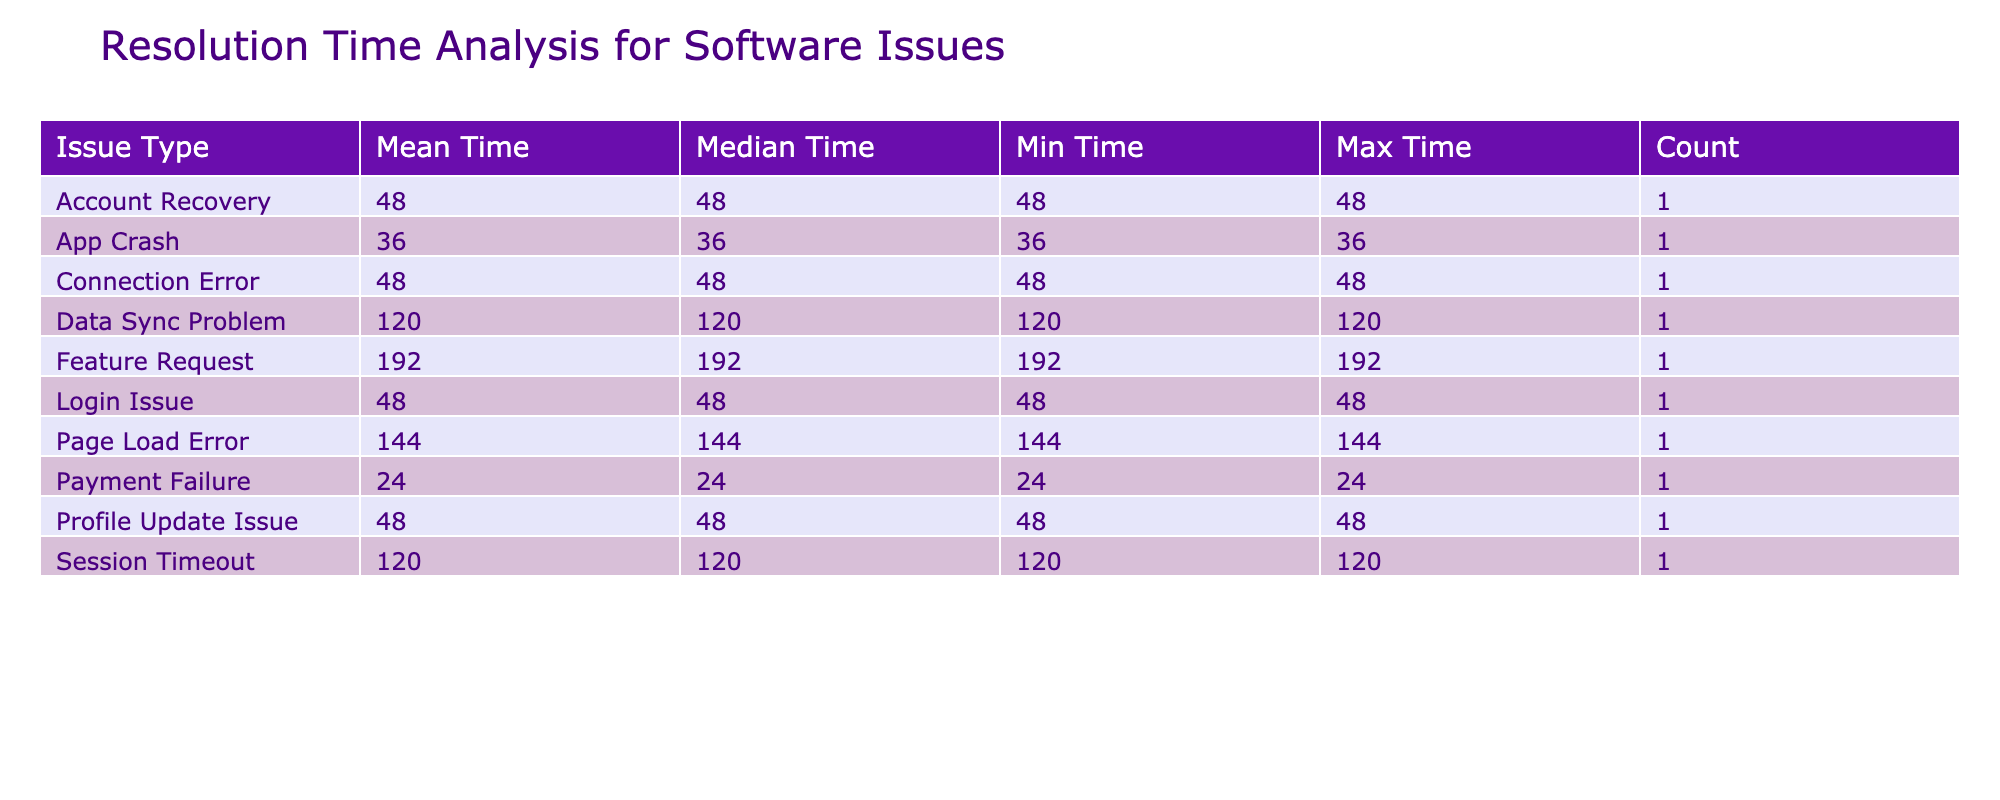What is the mean resolution time for Feature Requests? To find the mean resolution time for Feature Requests, we check the 'Feature Request' row in the table, which shows a mean time of 192 hours.
Answer: 192 hours How many issues had a resolution time of more than 100 hours? By checking the 'Resolution Time' column, we identify two issues with a resolution time greater than 100 hours: Feature Request (192 hours) and Data Sync Problem (120 hours), giving us a total of 2 issues.
Answer: 2 Is there a maximum resolution time that exceeds 200 hours? The maximum resolution time listed in the table is 192 hours for Feature Requests; therefore, no issue exceeds 200 hours.
Answer: No What is the median resolution time for Payment Failures? The 'Payment Failure' entry in the table shows a median resolution time of 24 hours.
Answer: 24 hours Which issue type has the highest average resolution time? Comparing the mean resolution times, Feature Requests (192 hours) has the highest average, followed by Data Sync Problems (120 hours) and others. Hence, it is the issue type with the highest average resolution time.
Answer: Feature Request What is the total count of issues resolved by James Smith? Looking at the 'Call Center Representative' column, we see one issue type resolved by James Smith, which is a Login Issue, indicating a total count of 1.
Answer: 1 Is the minimum resolution time for any issue zero hours? The minimum resolution time listed in the table is 24 hours for Payment Failures, which means no issue resolution time is zero hours.
Answer: No What is the range of resolution times across all issues? The range can be calculated by subtracting the minimum resolution time (24 hours) from the maximum resolution time (192 hours), giving us a range of 168 hours.
Answer: 168 hours How many issues were resolved in less than 50 hours? Only three issues are listed: Login Issue (48 hours), App Crash (36 hours), and Connection Error (48 hours), totaling 3 issues resolved in less than 50 hours.
Answer: 3 